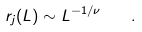Convert formula to latex. <formula><loc_0><loc_0><loc_500><loc_500>r _ { j } ( L ) \sim L ^ { - 1 / \nu } \quad .</formula> 